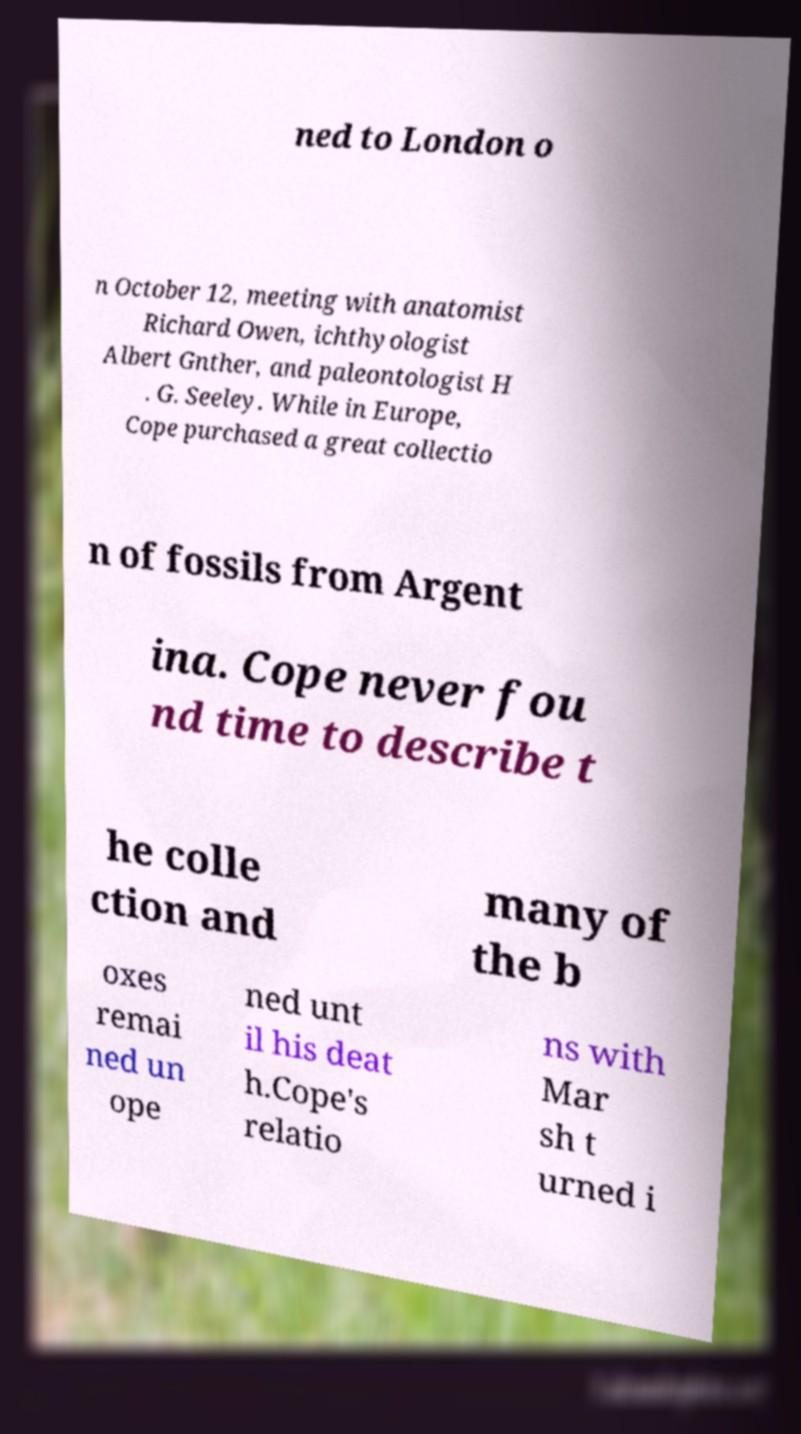Could you extract and type out the text from this image? ned to London o n October 12, meeting with anatomist Richard Owen, ichthyologist Albert Gnther, and paleontologist H . G. Seeley. While in Europe, Cope purchased a great collectio n of fossils from Argent ina. Cope never fou nd time to describe t he colle ction and many of the b oxes remai ned un ope ned unt il his deat h.Cope's relatio ns with Mar sh t urned i 